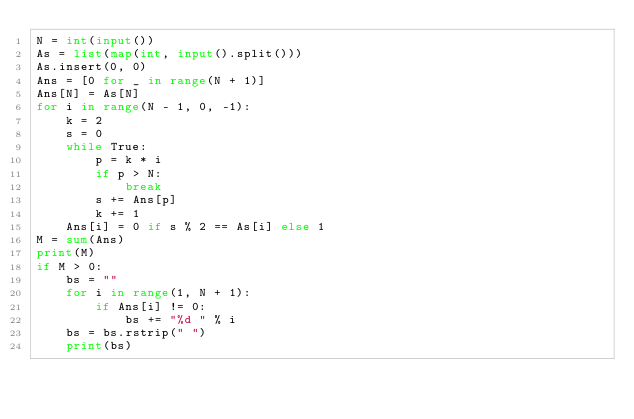Convert code to text. <code><loc_0><loc_0><loc_500><loc_500><_Python_>N = int(input())
As = list(map(int, input().split()))
As.insert(0, 0)
Ans = [0 for _ in range(N + 1)]
Ans[N] = As[N]
for i in range(N - 1, 0, -1):
    k = 2
    s = 0
    while True:
        p = k * i
        if p > N:
            break
        s += Ans[p]
        k += 1
    Ans[i] = 0 if s % 2 == As[i] else 1
M = sum(Ans)
print(M)
if M > 0:
    bs = ""
    for i in range(1, N + 1):
        if Ans[i] != 0:
            bs += "%d " % i
    bs = bs.rstrip(" ")
    print(bs)</code> 